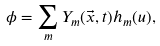Convert formula to latex. <formula><loc_0><loc_0><loc_500><loc_500>\phi = \sum _ { m } Y _ { m } ( \vec { x } , t ) h _ { m } ( u ) ,</formula> 